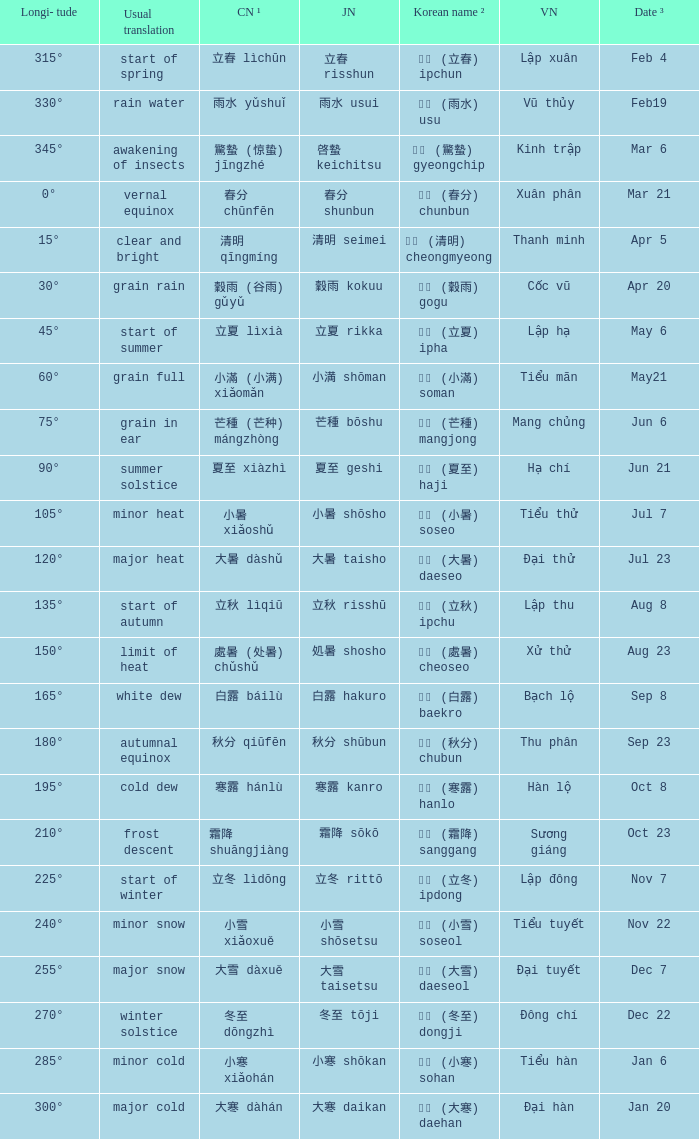WHICH Usual translation is on jun 21? Summer solstice. 